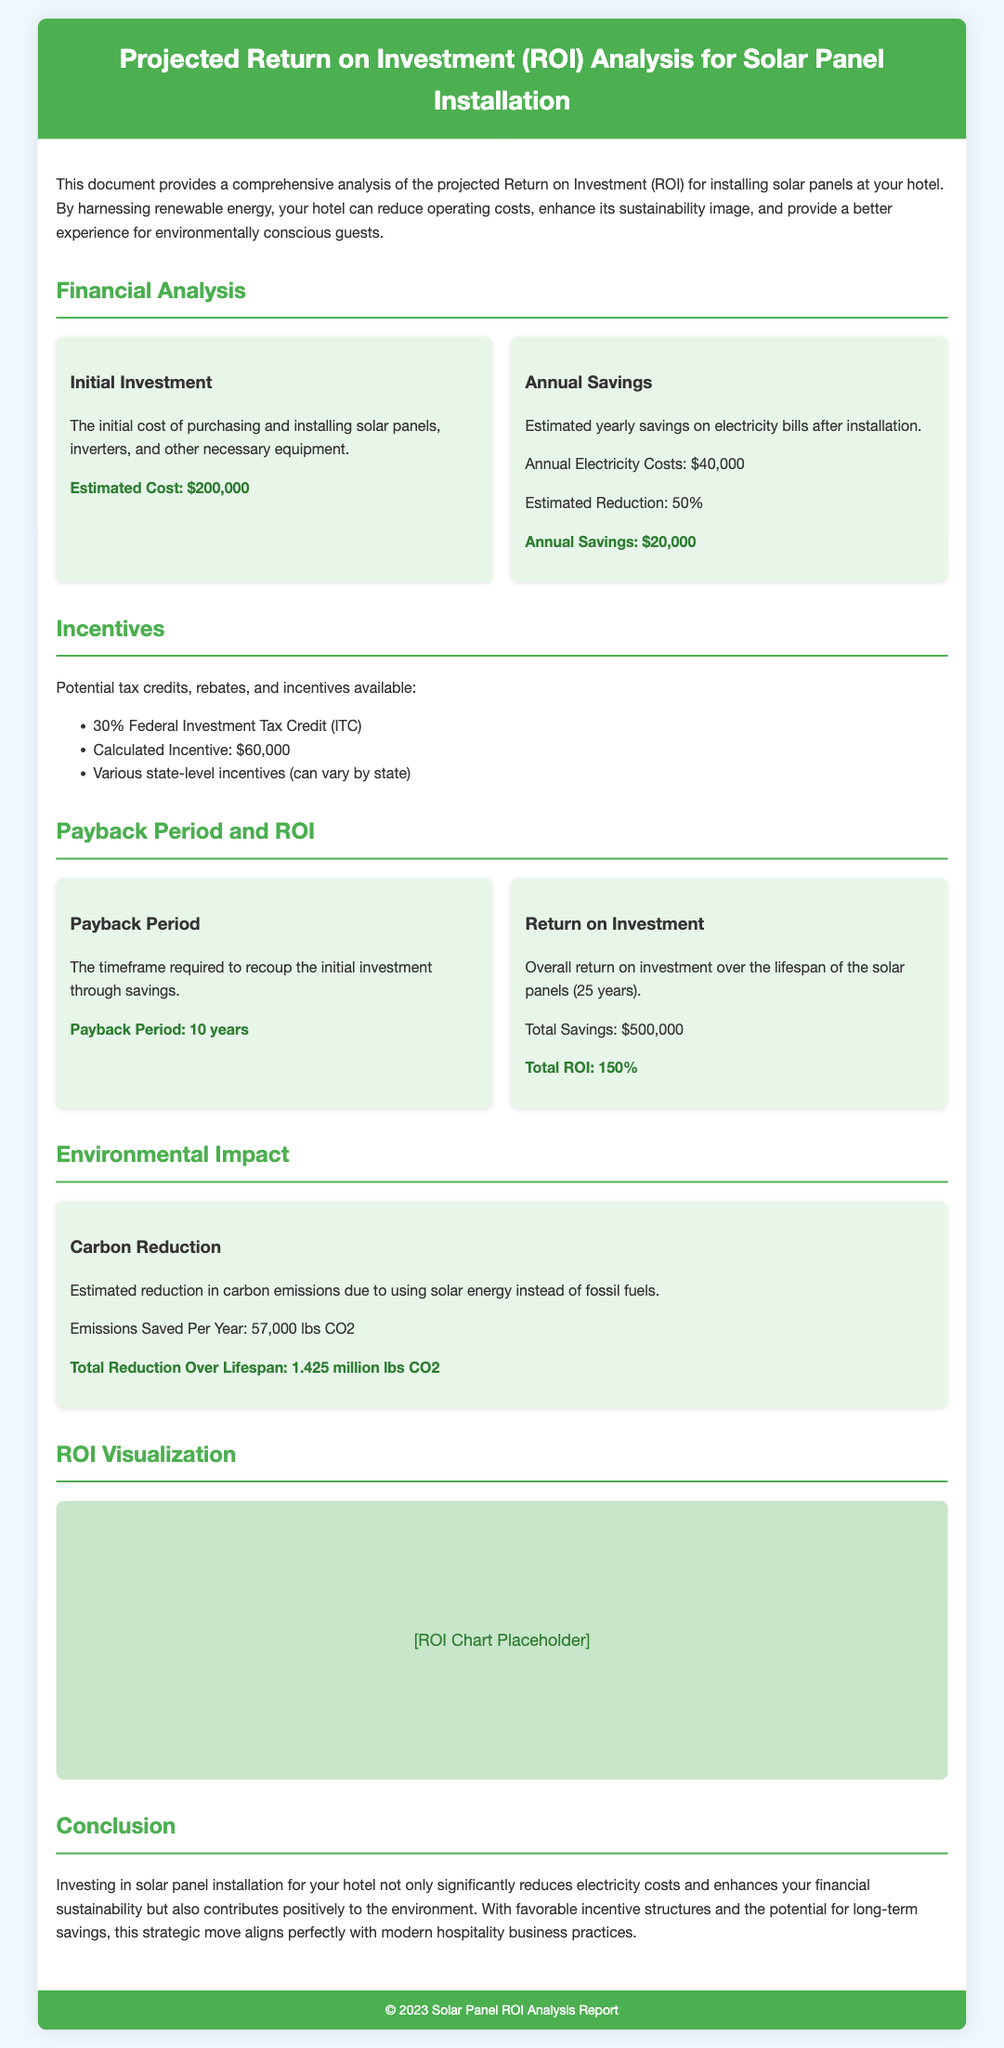what is the estimated cost of the initial investment? The document states that the estimated cost for purchasing and installing solar panels is $200,000.
Answer: $200,000 what are the annual savings after installing solar panels? According to the financial analysis, the annual savings identified is $20,000.
Answer: $20,000 what is the total reduction in carbon emissions over the lifespan of the solar panels? The document highlights that the total reduction over the lifespan is 1.425 million lbs CO2.
Answer: 1.425 million lbs CO2 how long is the payback period for the solar panel investment? The payback period specified in the document is 10 years.
Answer: 10 years what is the federal investment tax credit percentage applicable to the solar panel installation? The document lists the federal investment tax credit as 30%.
Answer: 30% what is the estimated annual electricity cost savings percentage? The estimated reduction percentage mentioned is 50%.
Answer: 50% how much is the total ROI over the lifespan of the solar panels? The document indicates that the total ROI is 150%.
Answer: 150% what does the analysis suggest about the environmental impact of the solar panel installation? The analysis mentions that the installation contributes positively to the environment by reducing carbon emissions.
Answer: Positive impact on the environment 